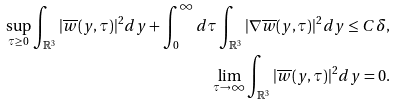<formula> <loc_0><loc_0><loc_500><loc_500>\sup _ { \tau \geq 0 } \int _ { \mathbb { R } ^ { 3 } } | \overline { w } ( y , \tau ) | ^ { 2 } d y + \int _ { 0 } ^ { \infty } d \tau \int _ { \mathbb { R } ^ { 3 } } | \nabla \overline { w } ( y , \tau ) | ^ { 2 } d y \leq C \delta , \\ \lim _ { \tau \to \infty } \int _ { \mathbb { R } ^ { 3 } } | \overline { w } ( y , \tau ) | ^ { 2 } d y = 0 .</formula> 